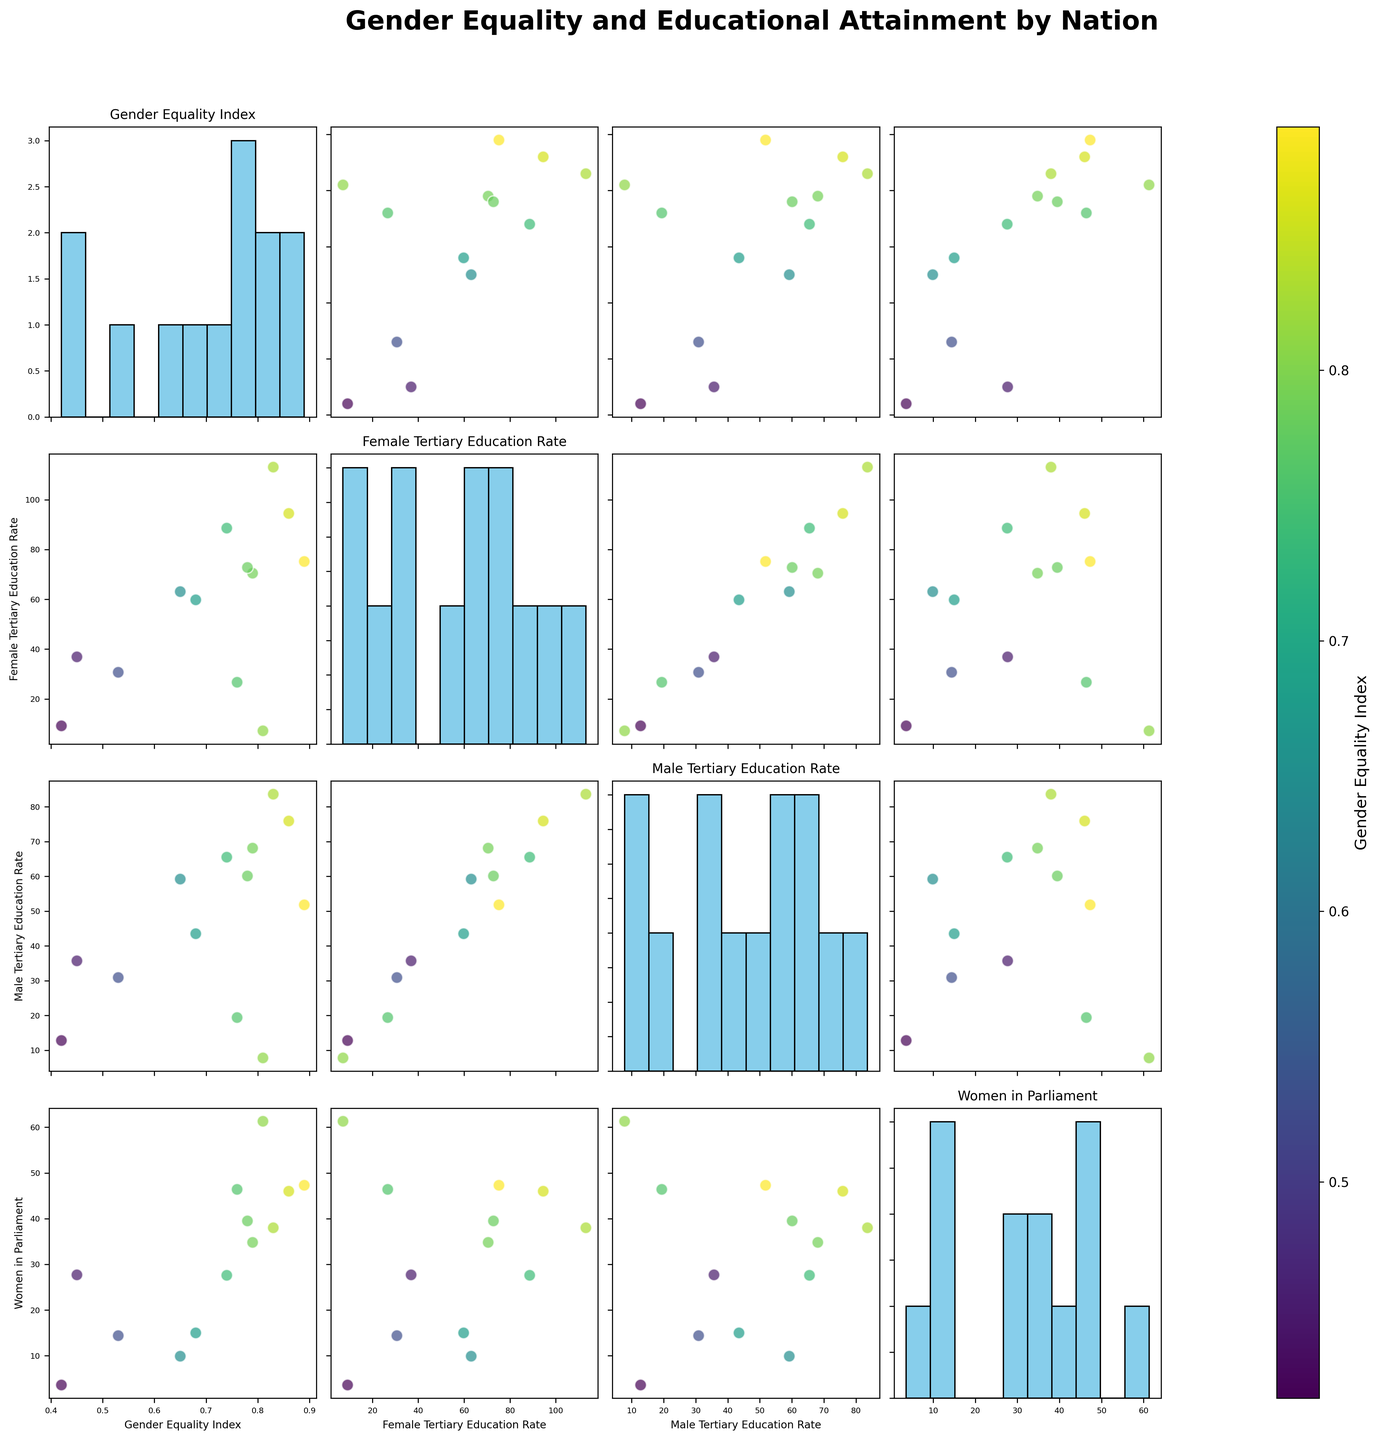What is the title of the figure? The title of the figure is given at the top of the plot in bold text.
Answer: Gender Equality and Educational Attainment by Nation How many features are compared in the scatterplot matrix? The scatterplot matrix compares multiple features visible from the titles on the histograms along the diagonal and the axis labels. Count the features: Gender Equality Index, Female Tertiary Education Rate, Male Tertiary Education Rate, and Women in Parliament.
Answer: 4 What is the color representing in the scatterplot matrix? The color bar on the side of the scatterplot matrix, with the label next to it, indicates the color coding. The color represents the Gender Equality Index.
Answer: Gender Equality Index How many countries have a Gender Equality Index above 0.8? By observing the scatterplots and the color intensity in the matrix, identify the points with a higher color intensity corresponding to values above 0.8. The countries with indices above 0.8 are Sweden, Rwanda, and Australia.
Answer: 3 Which country has the highest Female Tertiary Education Rate? The highest Female Tertiary Education Rate can be identified from the highest bar in the histogram along the diagonal under Female Tertiary Education Rate.
Answer: Australia How does the Women in Parliament percentage for Japan compare to Sweden? Locate the data points for Japan and Sweden in the scatterplot matrix under Women in Parliament vs Gender Equality Index. Japan has a lower percentage compared to Sweden.
Answer: Japan is lower Is there a relationship between Gender Equality Index and Female Tertiary Education Rate? Examine the scatterplot for Gender Equality Index vs. Female Tertiary Education Rate. The positive trend indicates a correlation between these variables.
Answer: Positive correlation Which country shows a greater disparity between Female and Male Tertiary Education Rates? In the scatterplot for Female Tertiary Education Rate vs. Male Tertiary Education Rate, note the countries with the largest vertical distance between the female and male rates. The largest gap is observed in the United States.
Answer: United States What is the range of Women in Parliament percentages? Check the histogram for Women in Parliament for the highest and lowest values. The lowest is around 3.6% (Nigeria), and the highest is about 61.3% (Rwanda).
Answer: 3.6% to 61.3% 